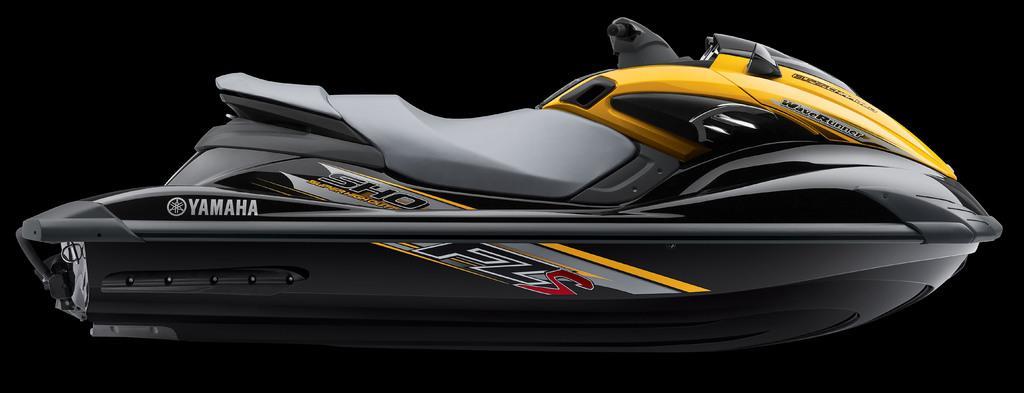Please provide a concise description of this image. In this picture I can observe waverunner boat. The boat is in black and yellow color. The background is dark. 